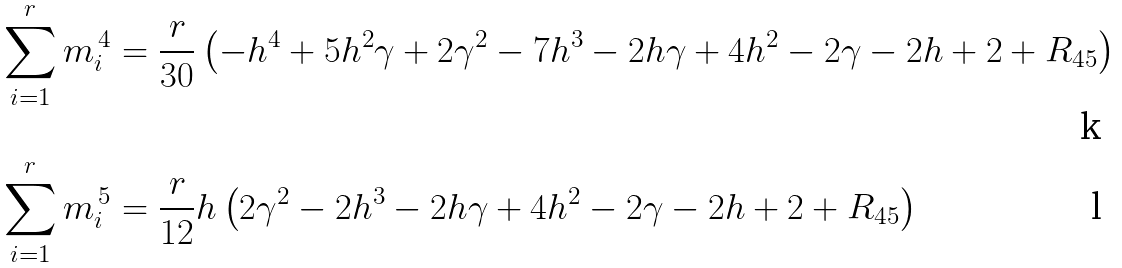Convert formula to latex. <formula><loc_0><loc_0><loc_500><loc_500>\sum _ { i = 1 } ^ { r } m _ { i } ^ { \, 4 } & = \frac { r } { 3 0 } \left ( - h ^ { 4 } + 5 h ^ { 2 } \gamma + 2 \gamma ^ { 2 } - 7 h ^ { 3 } - 2 h \gamma + 4 h ^ { 2 } - 2 \gamma - 2 h + 2 + R _ { 4 5 } \right ) \\ \sum _ { i = 1 } ^ { r } m _ { i } ^ { \, 5 } & = \frac { r } { 1 2 } h \left ( 2 \gamma ^ { 2 } - 2 h ^ { 3 } - 2 h \gamma + 4 h ^ { 2 } - 2 \gamma - 2 h + 2 + R _ { 4 5 } \right )</formula> 